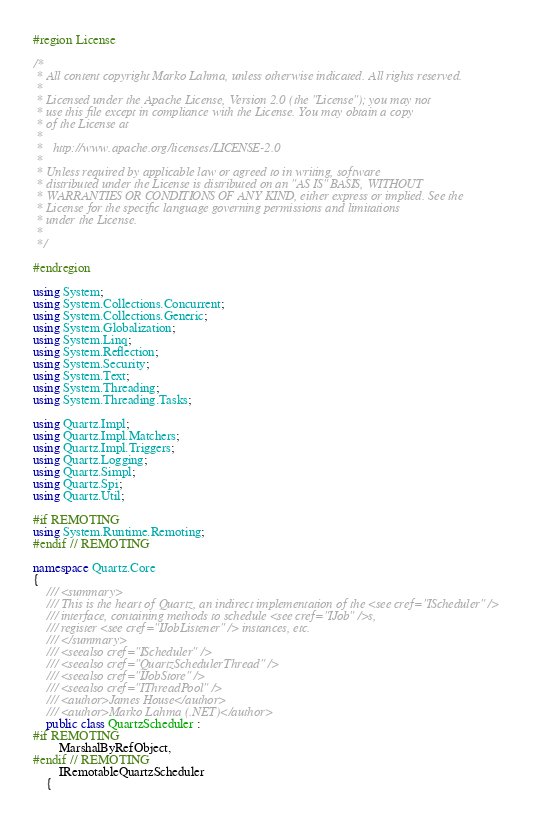<code> <loc_0><loc_0><loc_500><loc_500><_C#_>#region License

/*
 * All content copyright Marko Lahma, unless otherwise indicated. All rights reserved.
 *
 * Licensed under the Apache License, Version 2.0 (the "License"); you may not
 * use this file except in compliance with the License. You may obtain a copy
 * of the License at
 *
 *   http://www.apache.org/licenses/LICENSE-2.0
 *
 * Unless required by applicable law or agreed to in writing, software
 * distributed under the License is distributed on an "AS IS" BASIS, WITHOUT
 * WARRANTIES OR CONDITIONS OF ANY KIND, either express or implied. See the
 * License for the specific language governing permissions and limitations
 * under the License.
 *
 */

#endregion

using System;
using System.Collections.Concurrent;
using System.Collections.Generic;
using System.Globalization;
using System.Linq;
using System.Reflection;
using System.Security;
using System.Text;
using System.Threading;
using System.Threading.Tasks;

using Quartz.Impl;
using Quartz.Impl.Matchers;
using Quartz.Impl.Triggers;
using Quartz.Logging;
using Quartz.Simpl;
using Quartz.Spi;
using Quartz.Util;

#if REMOTING
using System.Runtime.Remoting;
#endif // REMOTING

namespace Quartz.Core
{
    /// <summary>
    /// This is the heart of Quartz, an indirect implementation of the <see cref="IScheduler" />
    /// interface, containing methods to schedule <see cref="IJob" />s,
    /// register <see cref="IJobListener" /> instances, etc.
    /// </summary>
    /// <seealso cref="IScheduler" />
    /// <seealso cref="QuartzSchedulerThread" />
    /// <seealso cref="IJobStore" />
    /// <seealso cref="IThreadPool" />
    /// <author>James House</author>
    /// <author>Marko Lahma (.NET)</author>
    public class QuartzScheduler :
#if REMOTING
        MarshalByRefObject,
#endif // REMOTING
        IRemotableQuartzScheduler
    {</code> 